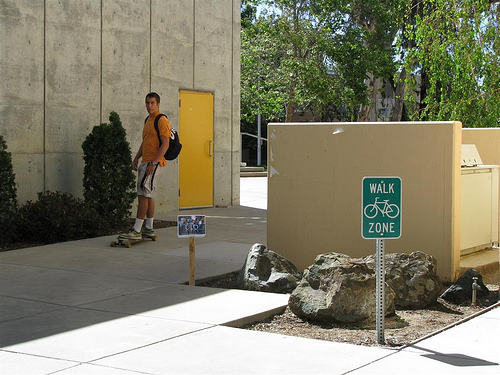<image>What does the blue sign say? It is unknown what the blue sign says. It might be 'walk zone' or 'cto'. However, there might not be a blue sign at all. What does the blue sign say? It is unknown what the blue sign says. It can be seen as 'walk zone', 'cto' or 'nothing'. 